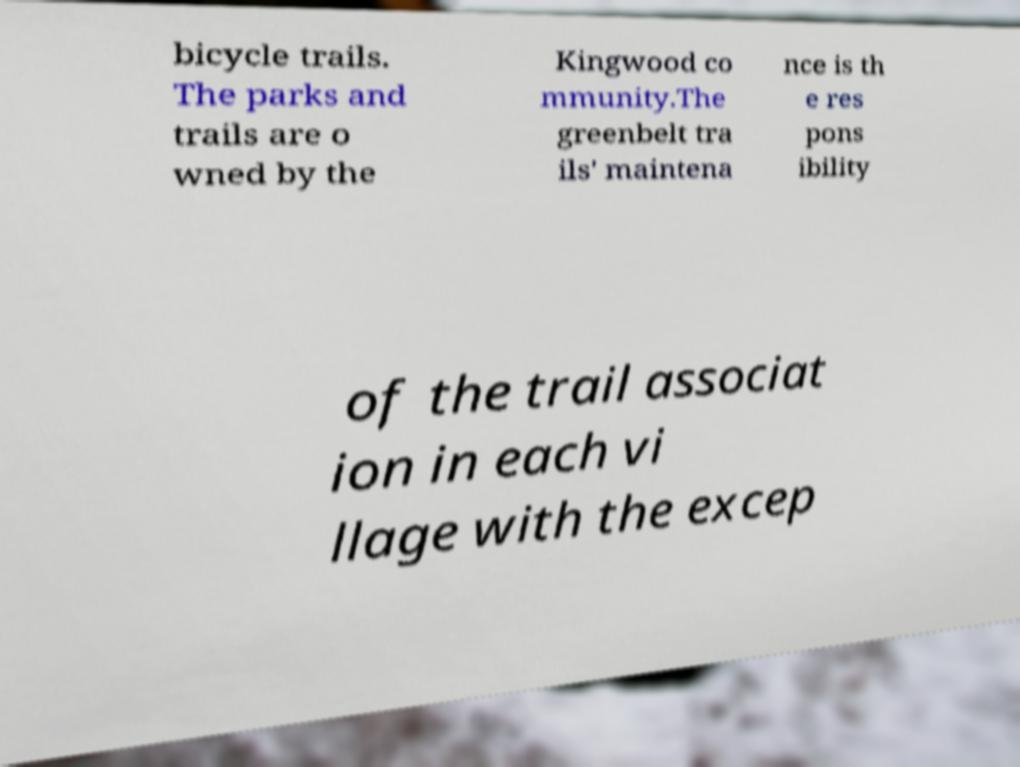I need the written content from this picture converted into text. Can you do that? bicycle trails. The parks and trails are o wned by the Kingwood co mmunity.The greenbelt tra ils' maintena nce is th e res pons ibility of the trail associat ion in each vi llage with the excep 